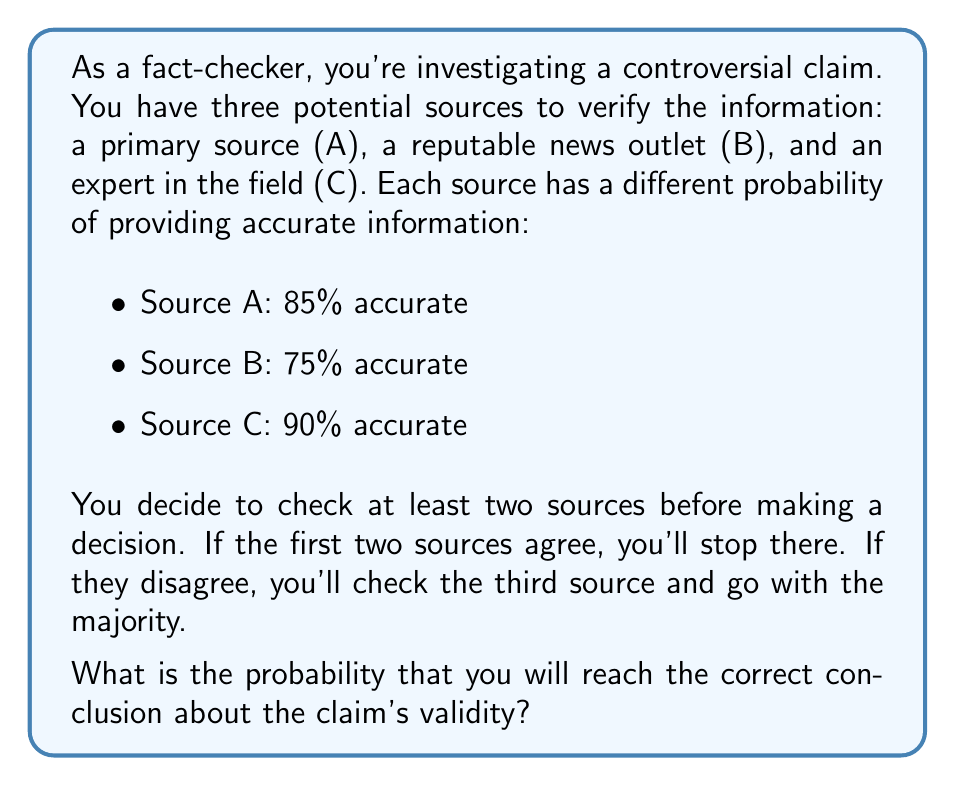Help me with this question. Let's approach this step-by-step using a decision tree analysis:

1) First, we need to consider all possible scenarios:

   a) A and B agree (both correct or both incorrect)
   b) A and B disagree, so we check C
   c) A and C agree (when A and B disagree)
   d) B and C agree (when A and B disagree)

2) Let's calculate the probabilities for each scenario:

   a) P(A and B both correct) = 0.85 * 0.75 = 0.6375
      P(A and B both incorrect) = 0.15 * 0.25 = 0.0375
      P(A and B agree) = 0.6375 + 0.0375 = 0.675

   b) P(A and B disagree) = 1 - 0.675 = 0.325

3) Now, let's calculate the probability of reaching the correct conclusion in each scenario:

   a) When A and B agree and are correct: 0.6375

   b) When A and B disagree and C is checked:
      P(C correct) = 0.90
      P(A correct, B incorrect) = 0.85 * 0.25 = 0.2125
      P(A incorrect, B correct) = 0.15 * 0.75 = 0.1125

      Correct conclusion when C agrees with A: 0.2125 * 0.90 = 0.19125
      Correct conclusion when C agrees with B: 0.1125 * 0.90 = 0.10125

4) Sum up all probabilities of reaching the correct conclusion:

   $$P(\text{correct}) = 0.6375 + (0.325 * 0.90) = 0.6375 + 0.2925 = 0.93$$

Therefore, the probability of reaching the correct conclusion is 0.93 or 93%.
Answer: 0.93 or 93% 